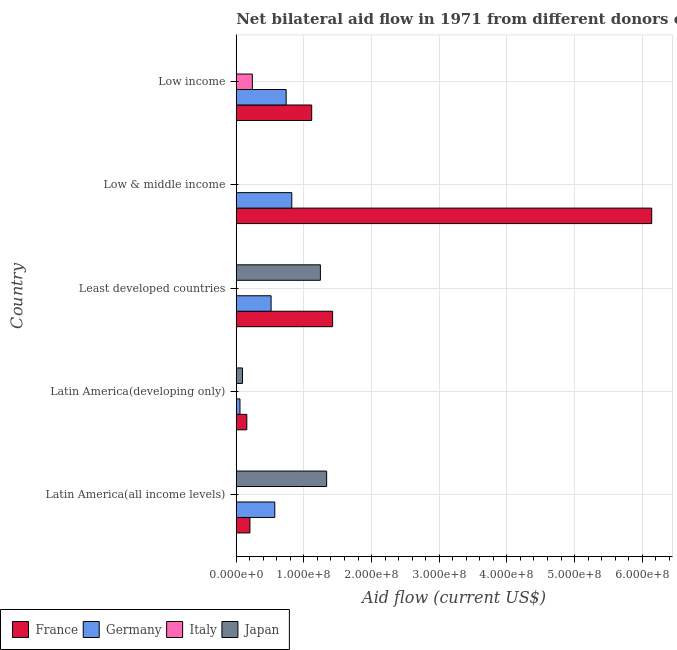How many different coloured bars are there?
Your response must be concise. 4. What is the label of the 4th group of bars from the top?
Offer a very short reply. Latin America(developing only). In how many cases, is the number of bars for a given country not equal to the number of legend labels?
Your answer should be very brief. 5. What is the amount of aid given by germany in Latin America(all income levels)?
Provide a succinct answer. 5.70e+07. Across all countries, what is the maximum amount of aid given by germany?
Your answer should be very brief. 8.21e+07. What is the total amount of aid given by france in the graph?
Provide a succinct answer. 9.04e+08. What is the difference between the amount of aid given by france in Latin America(developing only) and that in Low & middle income?
Provide a succinct answer. -5.98e+08. What is the difference between the amount of aid given by japan in Low & middle income and the amount of aid given by germany in Least developed countries?
Your answer should be compact. -5.15e+07. What is the average amount of aid given by italy per country?
Your answer should be very brief. 4.76e+06. What is the difference between the amount of aid given by japan and amount of aid given by germany in Latin America(developing only)?
Your response must be concise. 3.76e+06. In how many countries, is the amount of aid given by france greater than 200000000 US$?
Ensure brevity in your answer.  1. What is the ratio of the amount of aid given by germany in Latin America(all income levels) to that in Latin America(developing only)?
Offer a very short reply. 10.39. What is the difference between the highest and the second highest amount of aid given by germany?
Your answer should be very brief. 8.30e+06. What is the difference between the highest and the lowest amount of aid given by italy?
Offer a very short reply. 2.38e+07. Is the sum of the amount of aid given by france in Latin America(developing only) and Least developed countries greater than the maximum amount of aid given by japan across all countries?
Keep it short and to the point. Yes. Is it the case that in every country, the sum of the amount of aid given by france and amount of aid given by germany is greater than the amount of aid given by italy?
Offer a very short reply. Yes. How many bars are there?
Make the answer very short. 14. How many countries are there in the graph?
Keep it short and to the point. 5. What is the difference between two consecutive major ticks on the X-axis?
Your answer should be very brief. 1.00e+08. Does the graph contain any zero values?
Offer a very short reply. Yes. Does the graph contain grids?
Keep it short and to the point. Yes. Where does the legend appear in the graph?
Offer a terse response. Bottom left. How are the legend labels stacked?
Your answer should be very brief. Horizontal. What is the title of the graph?
Make the answer very short. Net bilateral aid flow in 1971 from different donors of Development Assistance Committee. Does "Primary schools" appear as one of the legend labels in the graph?
Ensure brevity in your answer.  No. What is the label or title of the X-axis?
Offer a very short reply. Aid flow (current US$). What is the label or title of the Y-axis?
Your response must be concise. Country. What is the Aid flow (current US$) of France in Latin America(all income levels)?
Make the answer very short. 2.02e+07. What is the Aid flow (current US$) in Germany in Latin America(all income levels)?
Offer a terse response. 5.70e+07. What is the Aid flow (current US$) in Italy in Latin America(all income levels)?
Give a very brief answer. 0. What is the Aid flow (current US$) of Japan in Latin America(all income levels)?
Your response must be concise. 1.34e+08. What is the Aid flow (current US$) of France in Latin America(developing only)?
Provide a succinct answer. 1.56e+07. What is the Aid flow (current US$) in Germany in Latin America(developing only)?
Ensure brevity in your answer.  5.48e+06. What is the Aid flow (current US$) of Italy in Latin America(developing only)?
Your answer should be very brief. 0. What is the Aid flow (current US$) in Japan in Latin America(developing only)?
Offer a very short reply. 9.24e+06. What is the Aid flow (current US$) of France in Least developed countries?
Provide a short and direct response. 1.42e+08. What is the Aid flow (current US$) in Germany in Least developed countries?
Offer a terse response. 5.15e+07. What is the Aid flow (current US$) of Italy in Least developed countries?
Offer a very short reply. 0. What is the Aid flow (current US$) in Japan in Least developed countries?
Make the answer very short. 1.24e+08. What is the Aid flow (current US$) in France in Low & middle income?
Offer a very short reply. 6.14e+08. What is the Aid flow (current US$) of Germany in Low & middle income?
Offer a terse response. 8.21e+07. What is the Aid flow (current US$) in Japan in Low & middle income?
Offer a very short reply. 0. What is the Aid flow (current US$) of France in Low income?
Your answer should be very brief. 1.12e+08. What is the Aid flow (current US$) in Germany in Low income?
Give a very brief answer. 7.38e+07. What is the Aid flow (current US$) of Italy in Low income?
Provide a short and direct response. 2.38e+07. Across all countries, what is the maximum Aid flow (current US$) in France?
Provide a short and direct response. 6.14e+08. Across all countries, what is the maximum Aid flow (current US$) in Germany?
Offer a terse response. 8.21e+07. Across all countries, what is the maximum Aid flow (current US$) in Italy?
Provide a short and direct response. 2.38e+07. Across all countries, what is the maximum Aid flow (current US$) of Japan?
Offer a terse response. 1.34e+08. Across all countries, what is the minimum Aid flow (current US$) of France?
Your answer should be compact. 1.56e+07. Across all countries, what is the minimum Aid flow (current US$) of Germany?
Make the answer very short. 5.48e+06. Across all countries, what is the minimum Aid flow (current US$) in Japan?
Offer a very short reply. 0. What is the total Aid flow (current US$) in France in the graph?
Keep it short and to the point. 9.04e+08. What is the total Aid flow (current US$) in Germany in the graph?
Offer a terse response. 2.70e+08. What is the total Aid flow (current US$) of Italy in the graph?
Make the answer very short. 2.38e+07. What is the total Aid flow (current US$) of Japan in the graph?
Offer a terse response. 2.67e+08. What is the difference between the Aid flow (current US$) in France in Latin America(all income levels) and that in Latin America(developing only)?
Make the answer very short. 4.60e+06. What is the difference between the Aid flow (current US$) in Germany in Latin America(all income levels) and that in Latin America(developing only)?
Your answer should be very brief. 5.15e+07. What is the difference between the Aid flow (current US$) in Japan in Latin America(all income levels) and that in Latin America(developing only)?
Offer a very short reply. 1.24e+08. What is the difference between the Aid flow (current US$) of France in Latin America(all income levels) and that in Least developed countries?
Keep it short and to the point. -1.22e+08. What is the difference between the Aid flow (current US$) of Germany in Latin America(all income levels) and that in Least developed countries?
Keep it short and to the point. 5.48e+06. What is the difference between the Aid flow (current US$) in Japan in Latin America(all income levels) and that in Least developed countries?
Provide a short and direct response. 9.24e+06. What is the difference between the Aid flow (current US$) in France in Latin America(all income levels) and that in Low & middle income?
Ensure brevity in your answer.  -5.94e+08. What is the difference between the Aid flow (current US$) in Germany in Latin America(all income levels) and that in Low & middle income?
Ensure brevity in your answer.  -2.51e+07. What is the difference between the Aid flow (current US$) of France in Latin America(all income levels) and that in Low income?
Keep it short and to the point. -9.13e+07. What is the difference between the Aid flow (current US$) in Germany in Latin America(all income levels) and that in Low income?
Make the answer very short. -1.68e+07. What is the difference between the Aid flow (current US$) in France in Latin America(developing only) and that in Least developed countries?
Your answer should be compact. -1.27e+08. What is the difference between the Aid flow (current US$) in Germany in Latin America(developing only) and that in Least developed countries?
Keep it short and to the point. -4.60e+07. What is the difference between the Aid flow (current US$) in Japan in Latin America(developing only) and that in Least developed countries?
Make the answer very short. -1.15e+08. What is the difference between the Aid flow (current US$) in France in Latin America(developing only) and that in Low & middle income?
Your answer should be very brief. -5.98e+08. What is the difference between the Aid flow (current US$) in Germany in Latin America(developing only) and that in Low & middle income?
Offer a very short reply. -7.66e+07. What is the difference between the Aid flow (current US$) in France in Latin America(developing only) and that in Low income?
Provide a succinct answer. -9.59e+07. What is the difference between the Aid flow (current US$) of Germany in Latin America(developing only) and that in Low income?
Provide a succinct answer. -6.83e+07. What is the difference between the Aid flow (current US$) in France in Least developed countries and that in Low & middle income?
Keep it short and to the point. -4.72e+08. What is the difference between the Aid flow (current US$) of Germany in Least developed countries and that in Low & middle income?
Your answer should be compact. -3.06e+07. What is the difference between the Aid flow (current US$) in France in Least developed countries and that in Low income?
Keep it short and to the point. 3.09e+07. What is the difference between the Aid flow (current US$) in Germany in Least developed countries and that in Low income?
Provide a short and direct response. -2.23e+07. What is the difference between the Aid flow (current US$) of France in Low & middle income and that in Low income?
Offer a very short reply. 5.02e+08. What is the difference between the Aid flow (current US$) in Germany in Low & middle income and that in Low income?
Provide a short and direct response. 8.30e+06. What is the difference between the Aid flow (current US$) in France in Latin America(all income levels) and the Aid flow (current US$) in Germany in Latin America(developing only)?
Offer a very short reply. 1.47e+07. What is the difference between the Aid flow (current US$) of France in Latin America(all income levels) and the Aid flow (current US$) of Japan in Latin America(developing only)?
Give a very brief answer. 1.10e+07. What is the difference between the Aid flow (current US$) in Germany in Latin America(all income levels) and the Aid flow (current US$) in Japan in Latin America(developing only)?
Offer a very short reply. 4.77e+07. What is the difference between the Aid flow (current US$) in France in Latin America(all income levels) and the Aid flow (current US$) in Germany in Least developed countries?
Offer a very short reply. -3.13e+07. What is the difference between the Aid flow (current US$) in France in Latin America(all income levels) and the Aid flow (current US$) in Japan in Least developed countries?
Give a very brief answer. -1.04e+08. What is the difference between the Aid flow (current US$) in Germany in Latin America(all income levels) and the Aid flow (current US$) in Japan in Least developed countries?
Your response must be concise. -6.74e+07. What is the difference between the Aid flow (current US$) of France in Latin America(all income levels) and the Aid flow (current US$) of Germany in Low & middle income?
Provide a short and direct response. -6.19e+07. What is the difference between the Aid flow (current US$) in France in Latin America(all income levels) and the Aid flow (current US$) in Germany in Low income?
Offer a very short reply. -5.36e+07. What is the difference between the Aid flow (current US$) of France in Latin America(all income levels) and the Aid flow (current US$) of Italy in Low income?
Give a very brief answer. -3.58e+06. What is the difference between the Aid flow (current US$) of Germany in Latin America(all income levels) and the Aid flow (current US$) of Italy in Low income?
Your answer should be compact. 3.32e+07. What is the difference between the Aid flow (current US$) of France in Latin America(developing only) and the Aid flow (current US$) of Germany in Least developed countries?
Offer a terse response. -3.59e+07. What is the difference between the Aid flow (current US$) of France in Latin America(developing only) and the Aid flow (current US$) of Japan in Least developed countries?
Make the answer very short. -1.09e+08. What is the difference between the Aid flow (current US$) of Germany in Latin America(developing only) and the Aid flow (current US$) of Japan in Least developed countries?
Ensure brevity in your answer.  -1.19e+08. What is the difference between the Aid flow (current US$) in France in Latin America(developing only) and the Aid flow (current US$) in Germany in Low & middle income?
Provide a succinct answer. -6.65e+07. What is the difference between the Aid flow (current US$) in France in Latin America(developing only) and the Aid flow (current US$) in Germany in Low income?
Provide a short and direct response. -5.82e+07. What is the difference between the Aid flow (current US$) in France in Latin America(developing only) and the Aid flow (current US$) in Italy in Low income?
Offer a very short reply. -8.18e+06. What is the difference between the Aid flow (current US$) of Germany in Latin America(developing only) and the Aid flow (current US$) of Italy in Low income?
Keep it short and to the point. -1.83e+07. What is the difference between the Aid flow (current US$) of France in Least developed countries and the Aid flow (current US$) of Germany in Low & middle income?
Ensure brevity in your answer.  6.03e+07. What is the difference between the Aid flow (current US$) in France in Least developed countries and the Aid flow (current US$) in Germany in Low income?
Offer a terse response. 6.86e+07. What is the difference between the Aid flow (current US$) in France in Least developed countries and the Aid flow (current US$) in Italy in Low income?
Offer a terse response. 1.19e+08. What is the difference between the Aid flow (current US$) of Germany in Least developed countries and the Aid flow (current US$) of Italy in Low income?
Your response must be concise. 2.77e+07. What is the difference between the Aid flow (current US$) of France in Low & middle income and the Aid flow (current US$) of Germany in Low income?
Your answer should be compact. 5.40e+08. What is the difference between the Aid flow (current US$) in France in Low & middle income and the Aid flow (current US$) in Italy in Low income?
Offer a very short reply. 5.90e+08. What is the difference between the Aid flow (current US$) in Germany in Low & middle income and the Aid flow (current US$) in Italy in Low income?
Ensure brevity in your answer.  5.83e+07. What is the average Aid flow (current US$) of France per country?
Ensure brevity in your answer.  1.81e+08. What is the average Aid flow (current US$) in Germany per country?
Offer a terse response. 5.39e+07. What is the average Aid flow (current US$) of Italy per country?
Your answer should be very brief. 4.76e+06. What is the average Aid flow (current US$) in Japan per country?
Make the answer very short. 5.34e+07. What is the difference between the Aid flow (current US$) of France and Aid flow (current US$) of Germany in Latin America(all income levels)?
Make the answer very short. -3.68e+07. What is the difference between the Aid flow (current US$) of France and Aid flow (current US$) of Japan in Latin America(all income levels)?
Make the answer very short. -1.13e+08. What is the difference between the Aid flow (current US$) of Germany and Aid flow (current US$) of Japan in Latin America(all income levels)?
Keep it short and to the point. -7.66e+07. What is the difference between the Aid flow (current US$) of France and Aid flow (current US$) of Germany in Latin America(developing only)?
Your answer should be compact. 1.01e+07. What is the difference between the Aid flow (current US$) of France and Aid flow (current US$) of Japan in Latin America(developing only)?
Offer a very short reply. 6.36e+06. What is the difference between the Aid flow (current US$) in Germany and Aid flow (current US$) in Japan in Latin America(developing only)?
Your answer should be very brief. -3.76e+06. What is the difference between the Aid flow (current US$) of France and Aid flow (current US$) of Germany in Least developed countries?
Provide a succinct answer. 9.09e+07. What is the difference between the Aid flow (current US$) of France and Aid flow (current US$) of Japan in Least developed countries?
Provide a succinct answer. 1.81e+07. What is the difference between the Aid flow (current US$) of Germany and Aid flow (current US$) of Japan in Least developed countries?
Keep it short and to the point. -7.29e+07. What is the difference between the Aid flow (current US$) of France and Aid flow (current US$) of Germany in Low & middle income?
Give a very brief answer. 5.32e+08. What is the difference between the Aid flow (current US$) in France and Aid flow (current US$) in Germany in Low income?
Offer a very short reply. 3.77e+07. What is the difference between the Aid flow (current US$) of France and Aid flow (current US$) of Italy in Low income?
Provide a short and direct response. 8.77e+07. What is the difference between the Aid flow (current US$) in Germany and Aid flow (current US$) in Italy in Low income?
Your response must be concise. 5.00e+07. What is the ratio of the Aid flow (current US$) of France in Latin America(all income levels) to that in Latin America(developing only)?
Your response must be concise. 1.29. What is the ratio of the Aid flow (current US$) of Germany in Latin America(all income levels) to that in Latin America(developing only)?
Ensure brevity in your answer.  10.39. What is the ratio of the Aid flow (current US$) of Japan in Latin America(all income levels) to that in Latin America(developing only)?
Make the answer very short. 14.46. What is the ratio of the Aid flow (current US$) in France in Latin America(all income levels) to that in Least developed countries?
Provide a short and direct response. 0.14. What is the ratio of the Aid flow (current US$) in Germany in Latin America(all income levels) to that in Least developed countries?
Provide a succinct answer. 1.11. What is the ratio of the Aid flow (current US$) of Japan in Latin America(all income levels) to that in Least developed countries?
Give a very brief answer. 1.07. What is the ratio of the Aid flow (current US$) in France in Latin America(all income levels) to that in Low & middle income?
Your answer should be very brief. 0.03. What is the ratio of the Aid flow (current US$) of Germany in Latin America(all income levels) to that in Low & middle income?
Your answer should be very brief. 0.69. What is the ratio of the Aid flow (current US$) of France in Latin America(all income levels) to that in Low income?
Your response must be concise. 0.18. What is the ratio of the Aid flow (current US$) of Germany in Latin America(all income levels) to that in Low income?
Your response must be concise. 0.77. What is the ratio of the Aid flow (current US$) in France in Latin America(developing only) to that in Least developed countries?
Provide a short and direct response. 0.11. What is the ratio of the Aid flow (current US$) in Germany in Latin America(developing only) to that in Least developed countries?
Your answer should be very brief. 0.11. What is the ratio of the Aid flow (current US$) in Japan in Latin America(developing only) to that in Least developed countries?
Offer a terse response. 0.07. What is the ratio of the Aid flow (current US$) in France in Latin America(developing only) to that in Low & middle income?
Your answer should be compact. 0.03. What is the ratio of the Aid flow (current US$) of Germany in Latin America(developing only) to that in Low & middle income?
Keep it short and to the point. 0.07. What is the ratio of the Aid flow (current US$) in France in Latin America(developing only) to that in Low income?
Offer a very short reply. 0.14. What is the ratio of the Aid flow (current US$) in Germany in Latin America(developing only) to that in Low income?
Keep it short and to the point. 0.07. What is the ratio of the Aid flow (current US$) of France in Least developed countries to that in Low & middle income?
Ensure brevity in your answer.  0.23. What is the ratio of the Aid flow (current US$) of Germany in Least developed countries to that in Low & middle income?
Your response must be concise. 0.63. What is the ratio of the Aid flow (current US$) in France in Least developed countries to that in Low income?
Your response must be concise. 1.28. What is the ratio of the Aid flow (current US$) of Germany in Least developed countries to that in Low income?
Ensure brevity in your answer.  0.7. What is the ratio of the Aid flow (current US$) of France in Low & middle income to that in Low income?
Keep it short and to the point. 5.51. What is the ratio of the Aid flow (current US$) in Germany in Low & middle income to that in Low income?
Keep it short and to the point. 1.11. What is the difference between the highest and the second highest Aid flow (current US$) in France?
Make the answer very short. 4.72e+08. What is the difference between the highest and the second highest Aid flow (current US$) in Germany?
Ensure brevity in your answer.  8.30e+06. What is the difference between the highest and the second highest Aid flow (current US$) of Japan?
Your response must be concise. 9.24e+06. What is the difference between the highest and the lowest Aid flow (current US$) in France?
Your answer should be very brief. 5.98e+08. What is the difference between the highest and the lowest Aid flow (current US$) of Germany?
Offer a terse response. 7.66e+07. What is the difference between the highest and the lowest Aid flow (current US$) of Italy?
Provide a succinct answer. 2.38e+07. What is the difference between the highest and the lowest Aid flow (current US$) in Japan?
Your answer should be very brief. 1.34e+08. 